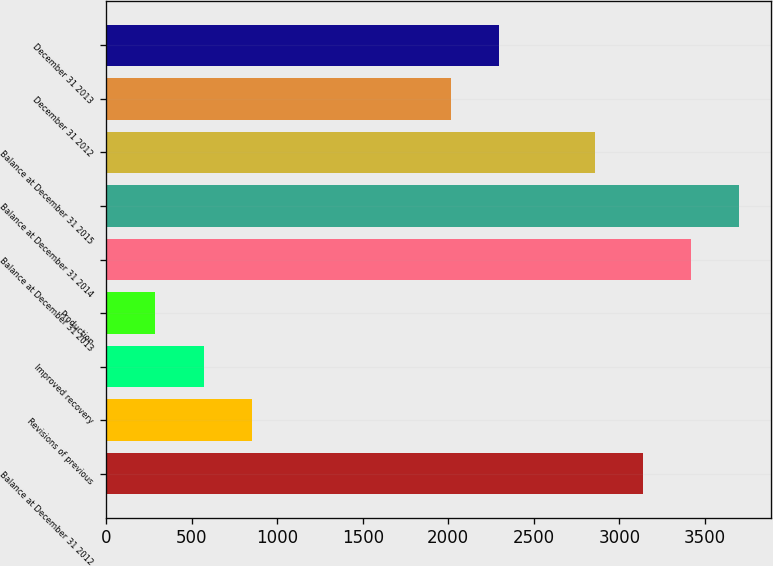<chart> <loc_0><loc_0><loc_500><loc_500><bar_chart><fcel>Balance at December 31 2012<fcel>Revisions of previous<fcel>Improved recovery<fcel>Production<fcel>Balance at December 31 2013<fcel>Balance at December 31 2014<fcel>Balance at December 31 2015<fcel>December 31 2012<fcel>December 31 2013<nl><fcel>3138<fcel>850.6<fcel>569.4<fcel>288.2<fcel>3419.2<fcel>3700.4<fcel>2856.8<fcel>2013.2<fcel>2294.4<nl></chart> 